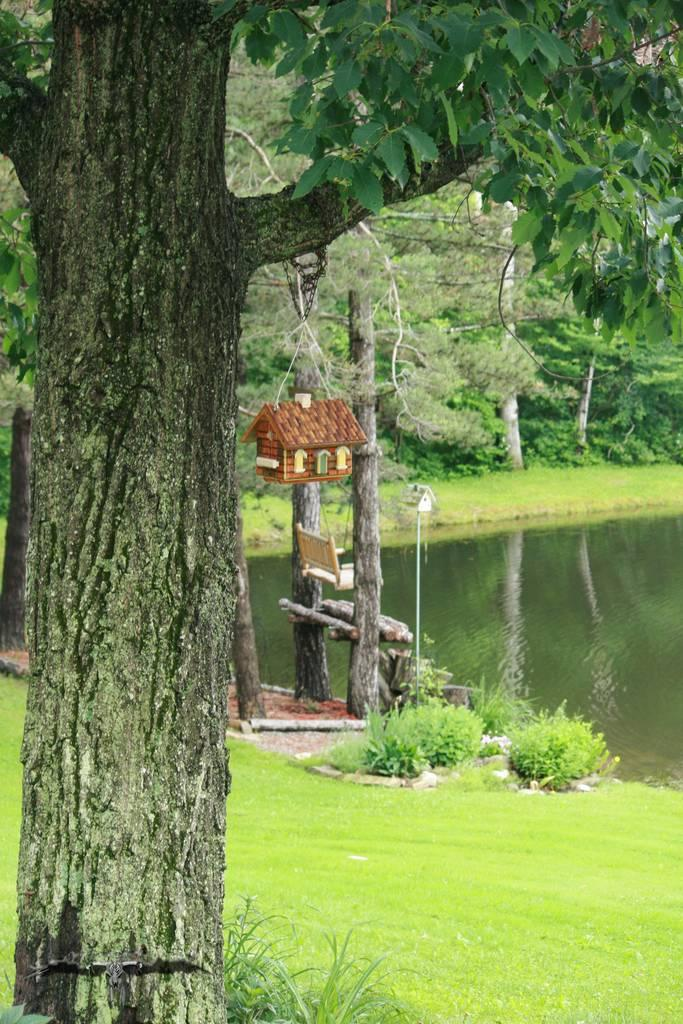What type of body of water is present in the image? There is a lake in the image. What is located in front of the lake? There is a pole in front of the lake. What is on top of the pole? There is a small hut house on the pole. What type of vegetation can be seen in the image? There are trees, grass, and plants visible in the image. How many babies are playing in the sleet near the lake in the image? There are no babies or sleet present in the image. 